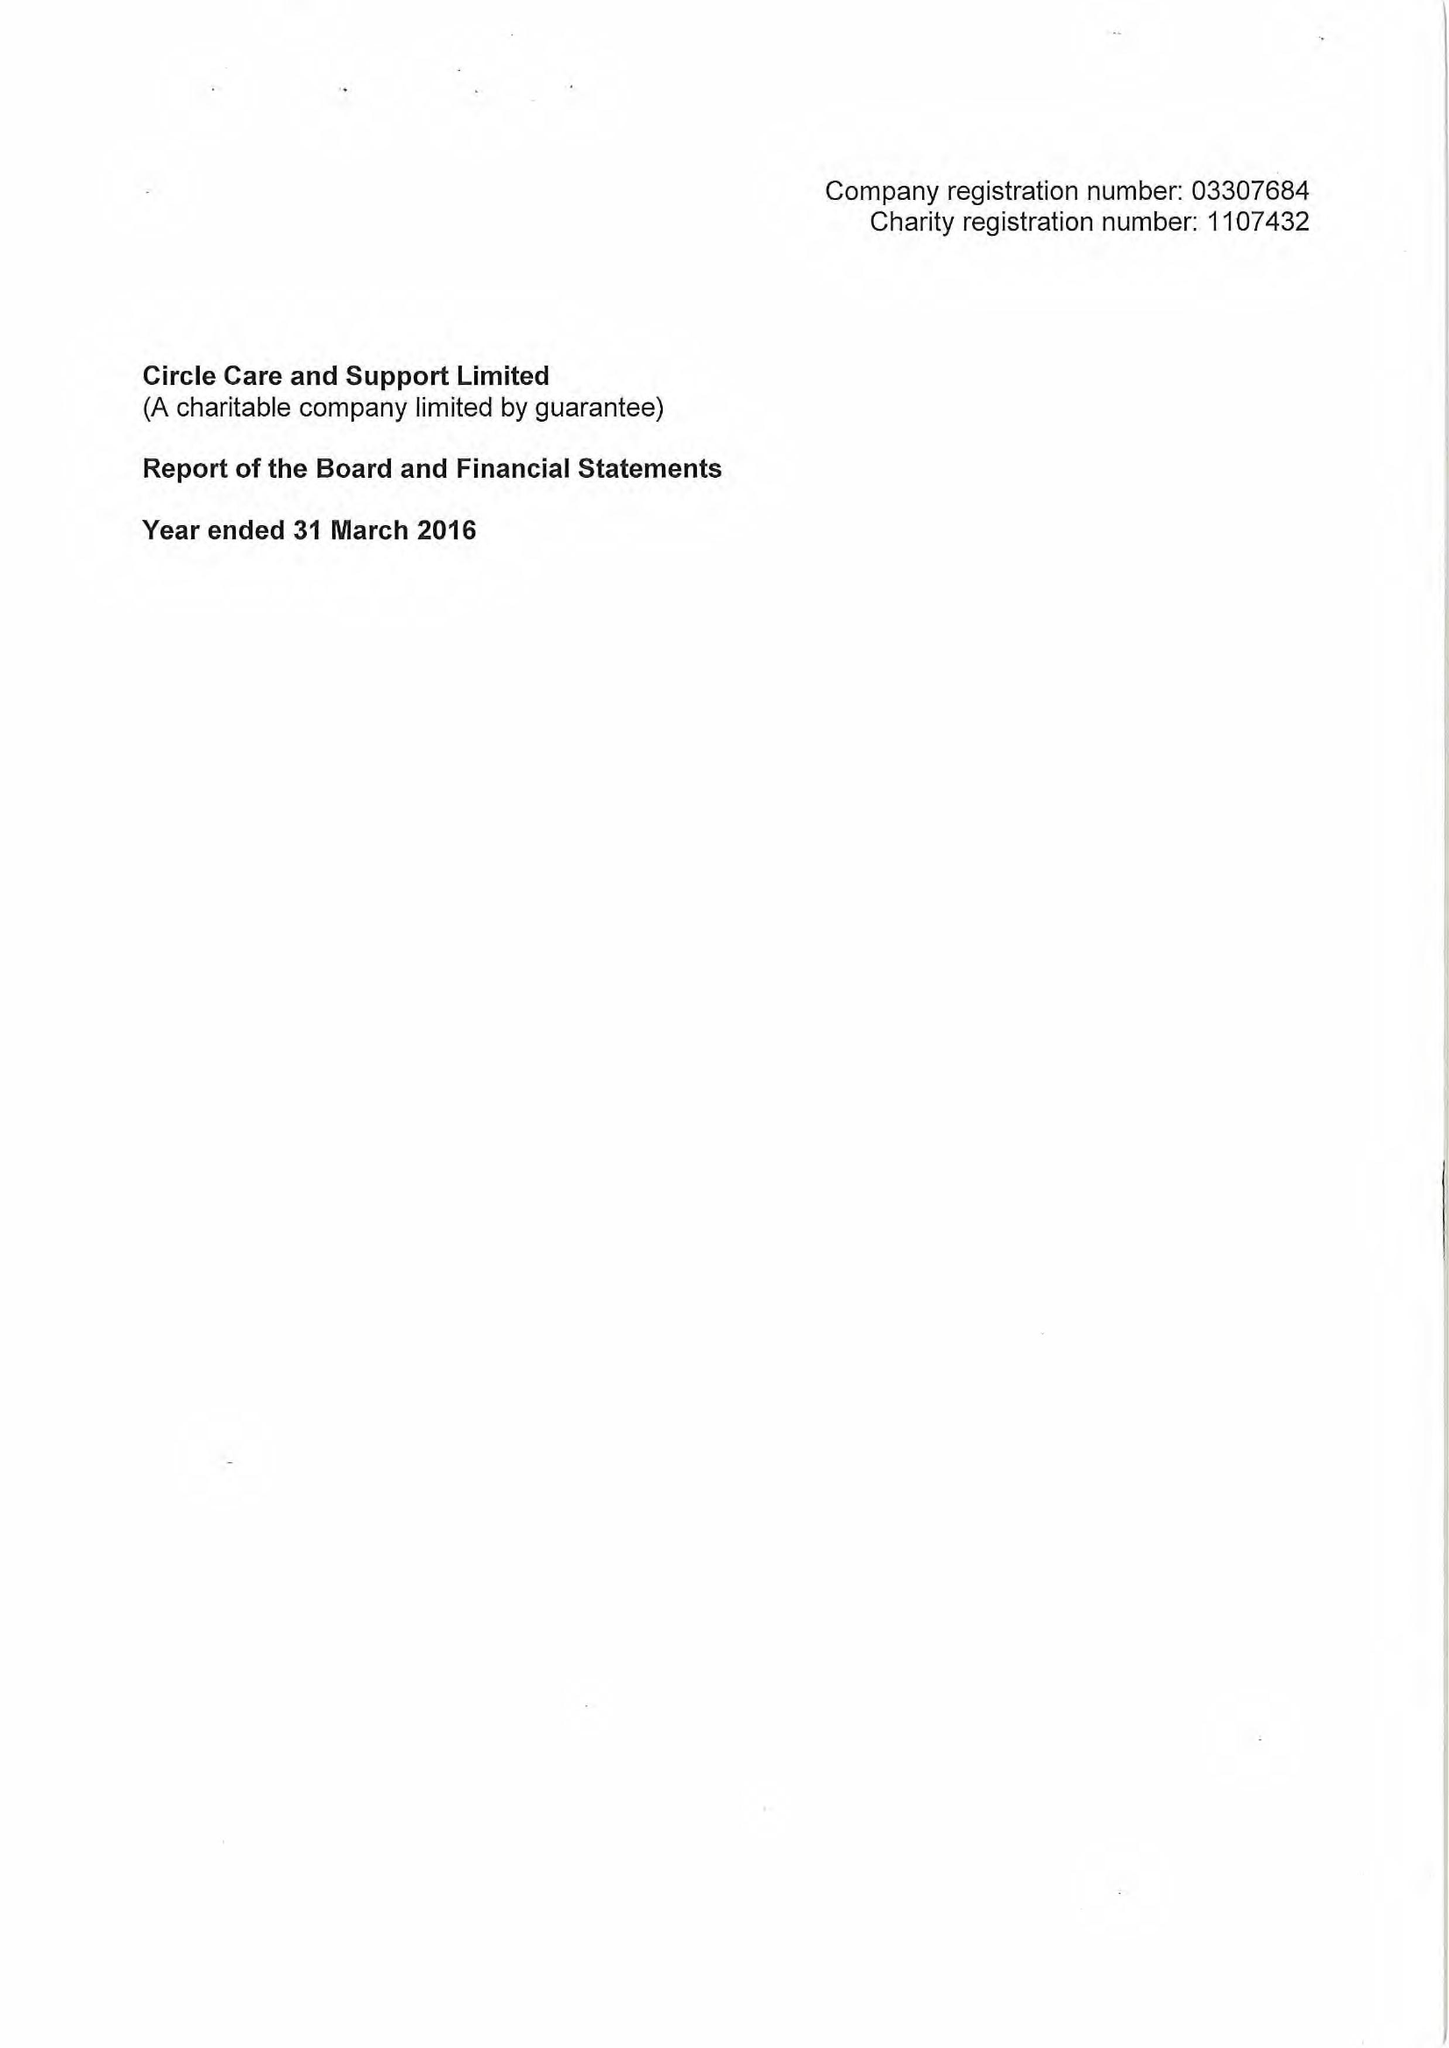What is the value for the address__street_line?
Answer the question using a single word or phrase. TOOLEY STREET 